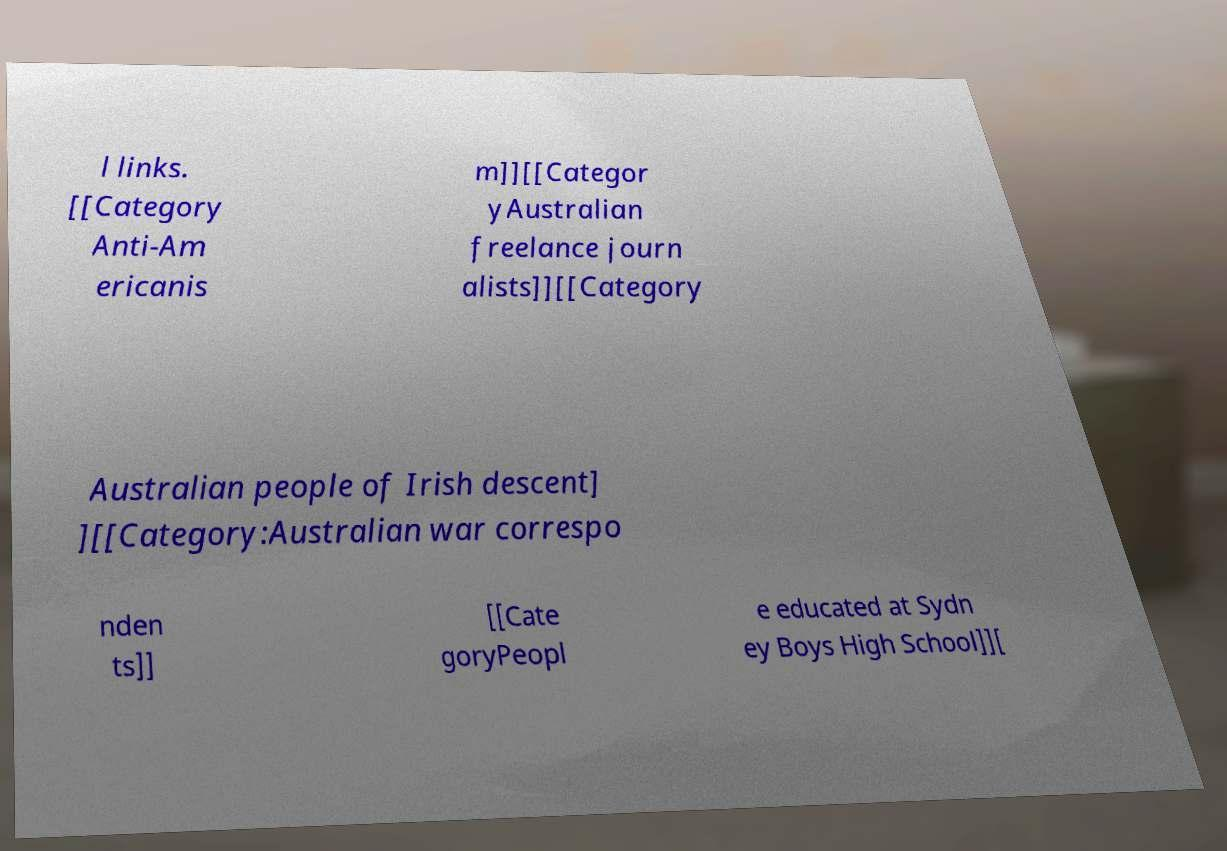I need the written content from this picture converted into text. Can you do that? l links. [[Category Anti-Am ericanis m]][[Categor yAustralian freelance journ alists]][[Category Australian people of Irish descent] ][[Category:Australian war correspo nden ts]] [[Cate goryPeopl e educated at Sydn ey Boys High School]][ 